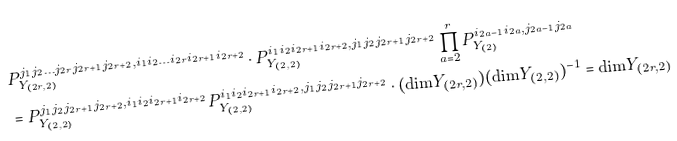<formula> <loc_0><loc_0><loc_500><loc_500>& P _ { Y _ { ( 2 r , 2 ) } } ^ { j _ { 1 } j _ { 2 } \dots j _ { 2 r } j _ { 2 r + 1 } j _ { 2 r + 2 } , i _ { 1 } i _ { 2 } \dots i _ { 2 r } i _ { 2 r + 1 } i _ { 2 r + 2 } } \cdot P _ { Y _ { ( 2 , 2 ) } } ^ { i _ { 1 } i _ { 2 } i _ { 2 r + 1 } i _ { 2 r + 2 } , j _ { 1 } j _ { 2 } j _ { 2 r + 1 } j _ { 2 r + 2 } } \prod _ { a = 2 } ^ { r } P _ { Y _ { ( 2 ) } } ^ { i _ { 2 a - 1 } i _ { 2 a } , j _ { 2 a - 1 } j _ { 2 a } } \\ & = P _ { Y _ { ( 2 , 2 ) } } ^ { j _ { 1 } j _ { 2 } j _ { 2 r + 1 } j _ { 2 r + 2 } , i _ { 1 } i _ { 2 } i _ { 2 r + 1 } i _ { 2 r + 2 } } P _ { Y _ { ( 2 , 2 ) } } ^ { i _ { 1 } i _ { 2 } i _ { 2 r + 1 } i _ { 2 r + 2 } , j _ { 1 } j _ { 2 } j _ { 2 r + 1 } j _ { 2 r + 2 } } \cdot ( \text {dim} Y _ { ( 2 r , 2 ) } ) ( \text {dim} Y _ { ( 2 , 2 ) } ) ^ { - 1 } = \text {dim} Y _ { ( 2 r , 2 ) }</formula> 